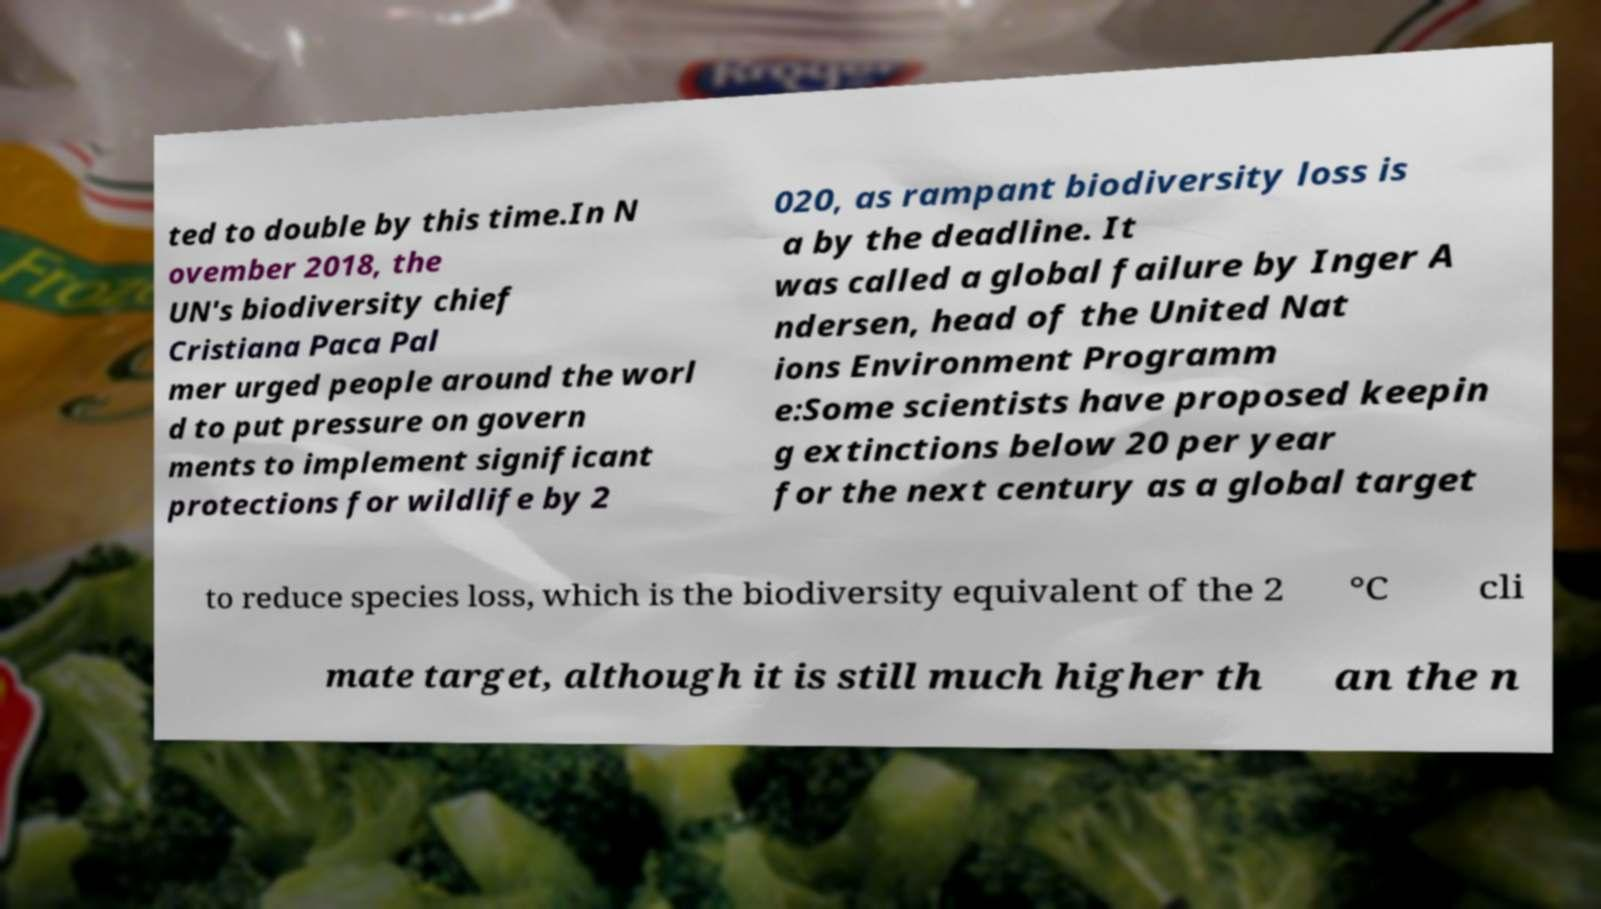Please read and relay the text visible in this image. What does it say? ted to double by this time.In N ovember 2018, the UN's biodiversity chief Cristiana Paca Pal mer urged people around the worl d to put pressure on govern ments to implement significant protections for wildlife by 2 020, as rampant biodiversity loss is a by the deadline. It was called a global failure by Inger A ndersen, head of the United Nat ions Environment Programm e:Some scientists have proposed keepin g extinctions below 20 per year for the next century as a global target to reduce species loss, which is the biodiversity equivalent of the 2 °C cli mate target, although it is still much higher th an the n 